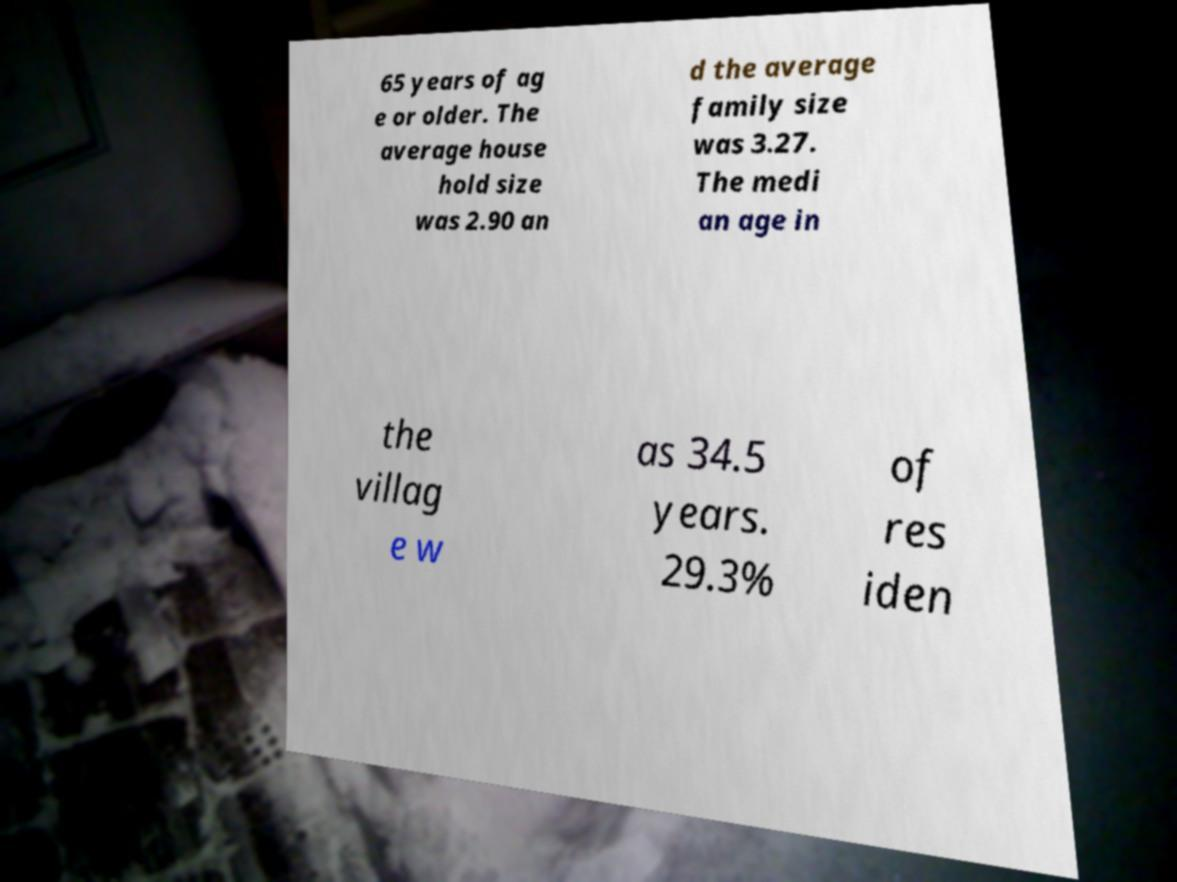What messages or text are displayed in this image? I need them in a readable, typed format. 65 years of ag e or older. The average house hold size was 2.90 an d the average family size was 3.27. The medi an age in the villag e w as 34.5 years. 29.3% of res iden 